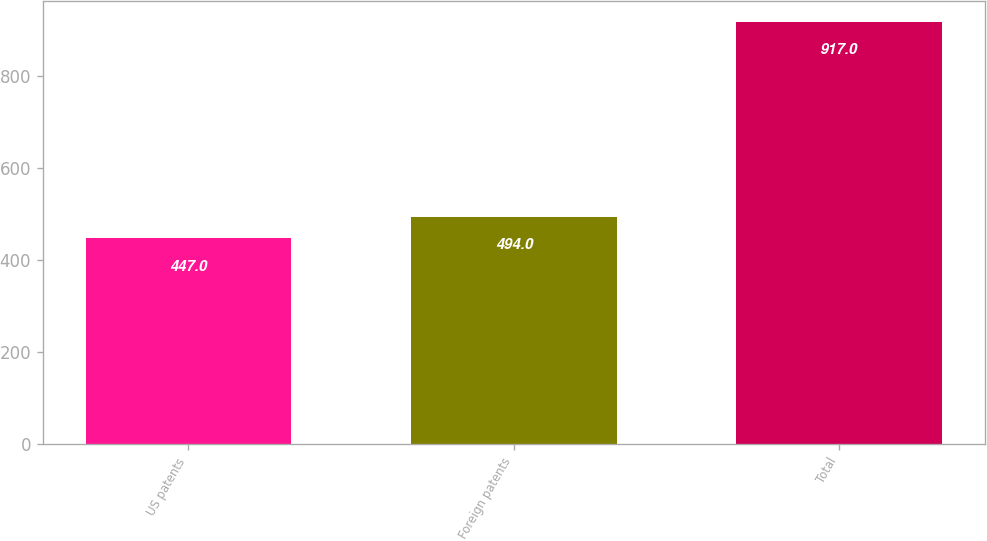Convert chart to OTSL. <chart><loc_0><loc_0><loc_500><loc_500><bar_chart><fcel>US patents<fcel>Foreign patents<fcel>Total<nl><fcel>447<fcel>494<fcel>917<nl></chart> 